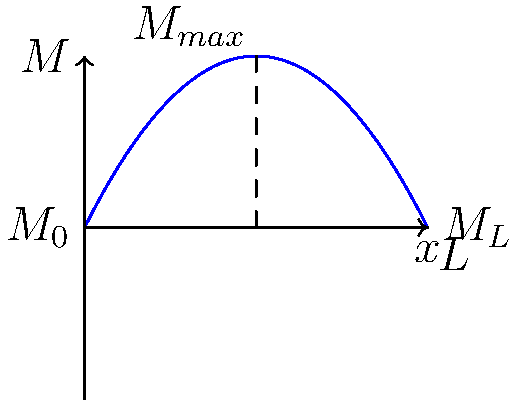In "The Mole" series, contestants often face challenges that test their problem-solving skills. Imagine a challenge where contestants must analyze a simply supported beam of length $L$ with a uniformly distributed load. Given the bending moment diagram shown above, determine the ratio of the maximum bending moment $M_{max}$ to the moment at the left support $M_0$. Let's approach this step-by-step, as if we're uncovering clues in "The Mole":

1) The bending moment diagram for a simply supported beam with a uniformly distributed load is a parabola.

2) The maximum bending moment occurs at the center of the beam (at $x = L/2$).

3) From the properties of a parabola, we know that:
   $M_0 = M_L = \frac{1}{8}wL^2$, where $w$ is the uniformly distributed load.

4) The maximum bending moment is:
   $M_{max} = \frac{1}{8}wL^2$

5) To find the ratio $M_{max}/M_0$, we divide these values:

   $$\frac{M_{max}}{M_0} = \frac{\frac{1}{8}wL^2}{\frac{1}{8}wL^2} = 2$$

This ratio is always 2, regardless of the specific values of $w$ and $L$. Just as in "The Mole", the key is recognizing the pattern, not getting caught up in specific numbers!
Answer: 2 